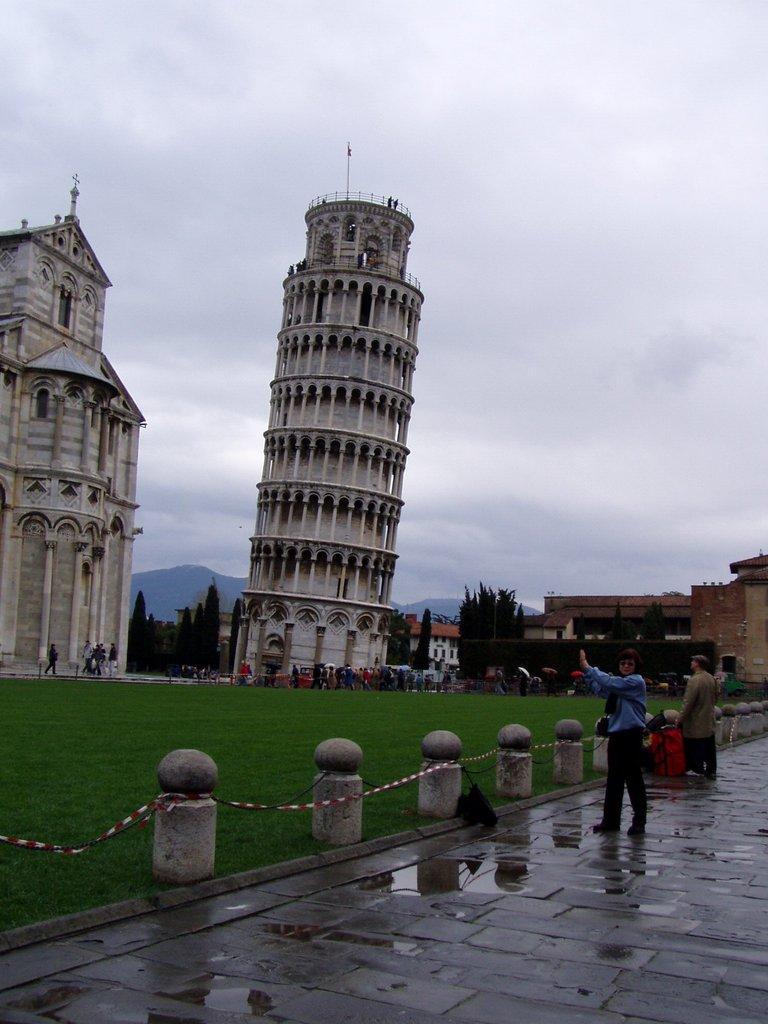Can you describe this image briefly? Here in this picture we can see a leaning tower present on the ground and beside that we can see a church building present and on the right side we can see some other buildings present and we can see the ground is fully covered with grass and we can see number of people standing and walking on the ground and in the far we can see plants and trees present and we can also see mountains present and we can see the sky is fully covered with clouds. 